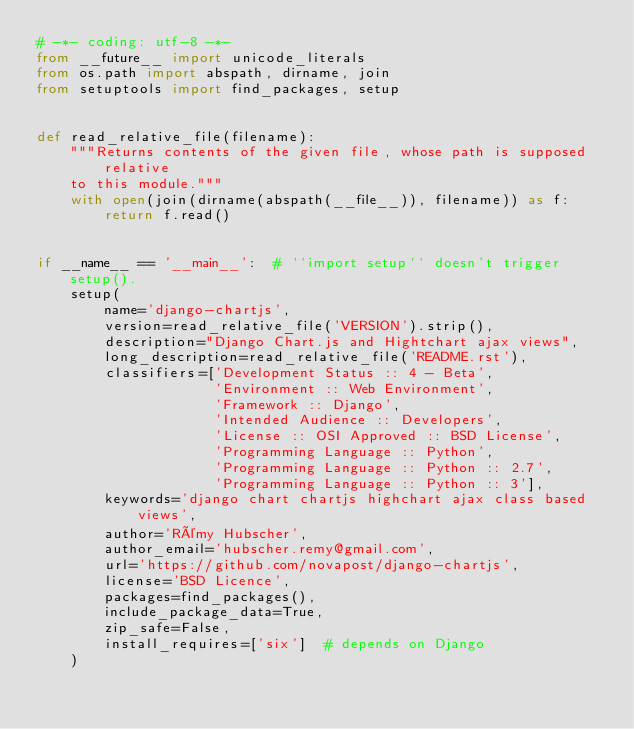Convert code to text. <code><loc_0><loc_0><loc_500><loc_500><_Python_># -*- coding: utf-8 -*-
from __future__ import unicode_literals
from os.path import abspath, dirname, join
from setuptools import find_packages, setup


def read_relative_file(filename):
    """Returns contents of the given file, whose path is supposed relative
    to this module."""
    with open(join(dirname(abspath(__file__)), filename)) as f:
        return f.read()


if __name__ == '__main__':  # ``import setup`` doesn't trigger setup().
    setup(
        name='django-chartjs',
        version=read_relative_file('VERSION').strip(),
        description="Django Chart.js and Hightchart ajax views",
        long_description=read_relative_file('README.rst'),
        classifiers=['Development Status :: 4 - Beta',
                     'Environment :: Web Environment',
                     'Framework :: Django',
                     'Intended Audience :: Developers',
                     'License :: OSI Approved :: BSD License',
                     'Programming Language :: Python',
                     'Programming Language :: Python :: 2.7',
                     'Programming Language :: Python :: 3'],
        keywords='django chart chartjs highchart ajax class based views',
        author='Rémy Hubscher',
        author_email='hubscher.remy@gmail.com',
        url='https://github.com/novapost/django-chartjs',
        license='BSD Licence',
        packages=find_packages(),
        include_package_data=True,
        zip_safe=False,
        install_requires=['six']  # depends on Django
    )
</code> 